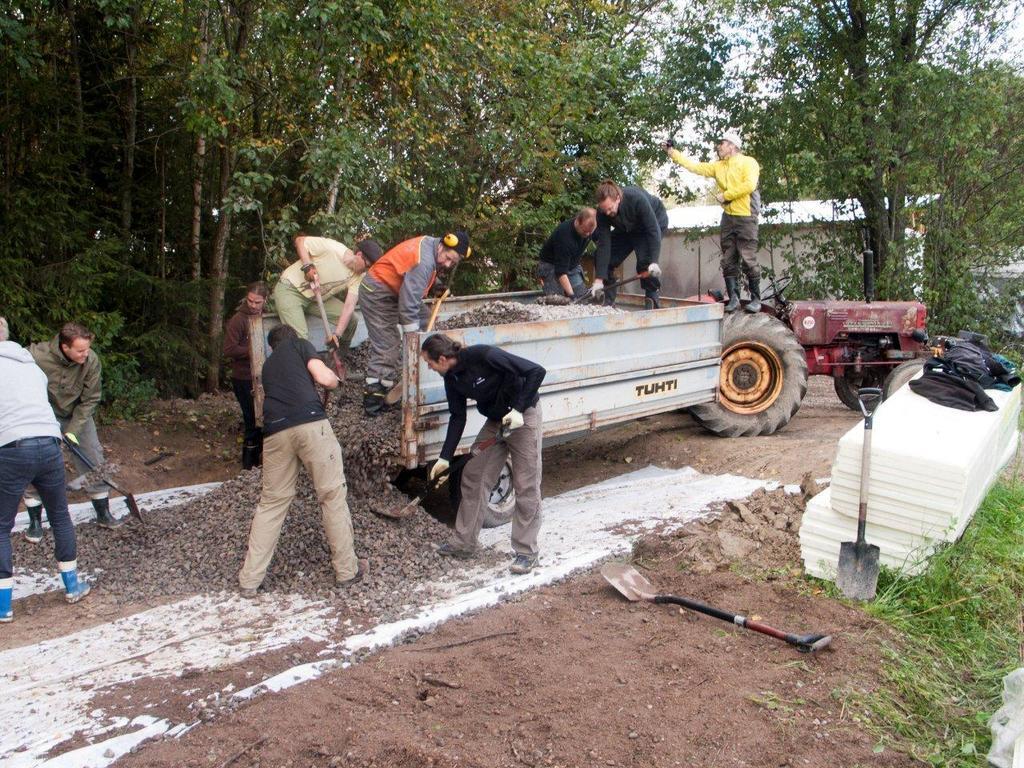Describe this image in one or two sentences. In the center of the image there is a vehicle and we can see people loading stones into the vehicle. At the bottom we can see a shovel. On the left there are two people working. In the background there are trees and building. 